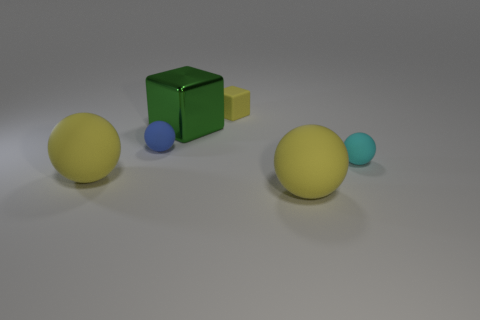There is a block that is the same material as the blue ball; what color is it?
Ensure brevity in your answer.  Yellow. What number of objects are either blue rubber objects or big yellow spheres?
Provide a succinct answer. 3. There is a sphere that is the same size as the cyan thing; what is its color?
Provide a succinct answer. Blue. What number of things are yellow rubber objects behind the small cyan rubber object or matte balls?
Provide a succinct answer. 5. What number of other things are the same size as the green thing?
Offer a terse response. 2. What is the size of the cube in front of the tiny block?
Make the answer very short. Large. What shape is the small yellow thing that is made of the same material as the cyan object?
Your answer should be very brief. Cube. Is there any other thing that has the same color as the large metallic cube?
Your answer should be very brief. No. What is the color of the large ball on the left side of the ball behind the cyan thing?
Your answer should be very brief. Yellow. What number of tiny objects are either brown metallic spheres or shiny cubes?
Offer a very short reply. 0. 